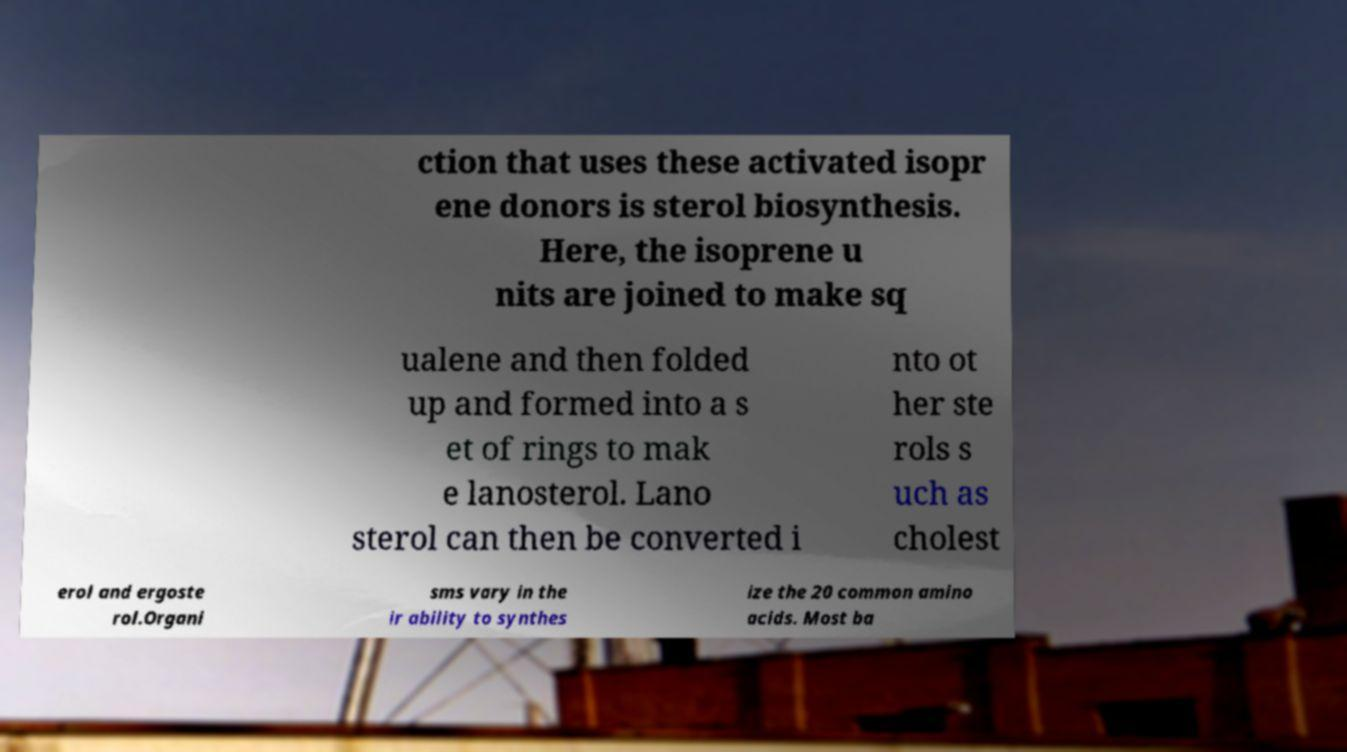What messages or text are displayed in this image? I need them in a readable, typed format. ction that uses these activated isopr ene donors is sterol biosynthesis. Here, the isoprene u nits are joined to make sq ualene and then folded up and formed into a s et of rings to mak e lanosterol. Lano sterol can then be converted i nto ot her ste rols s uch as cholest erol and ergoste rol.Organi sms vary in the ir ability to synthes ize the 20 common amino acids. Most ba 